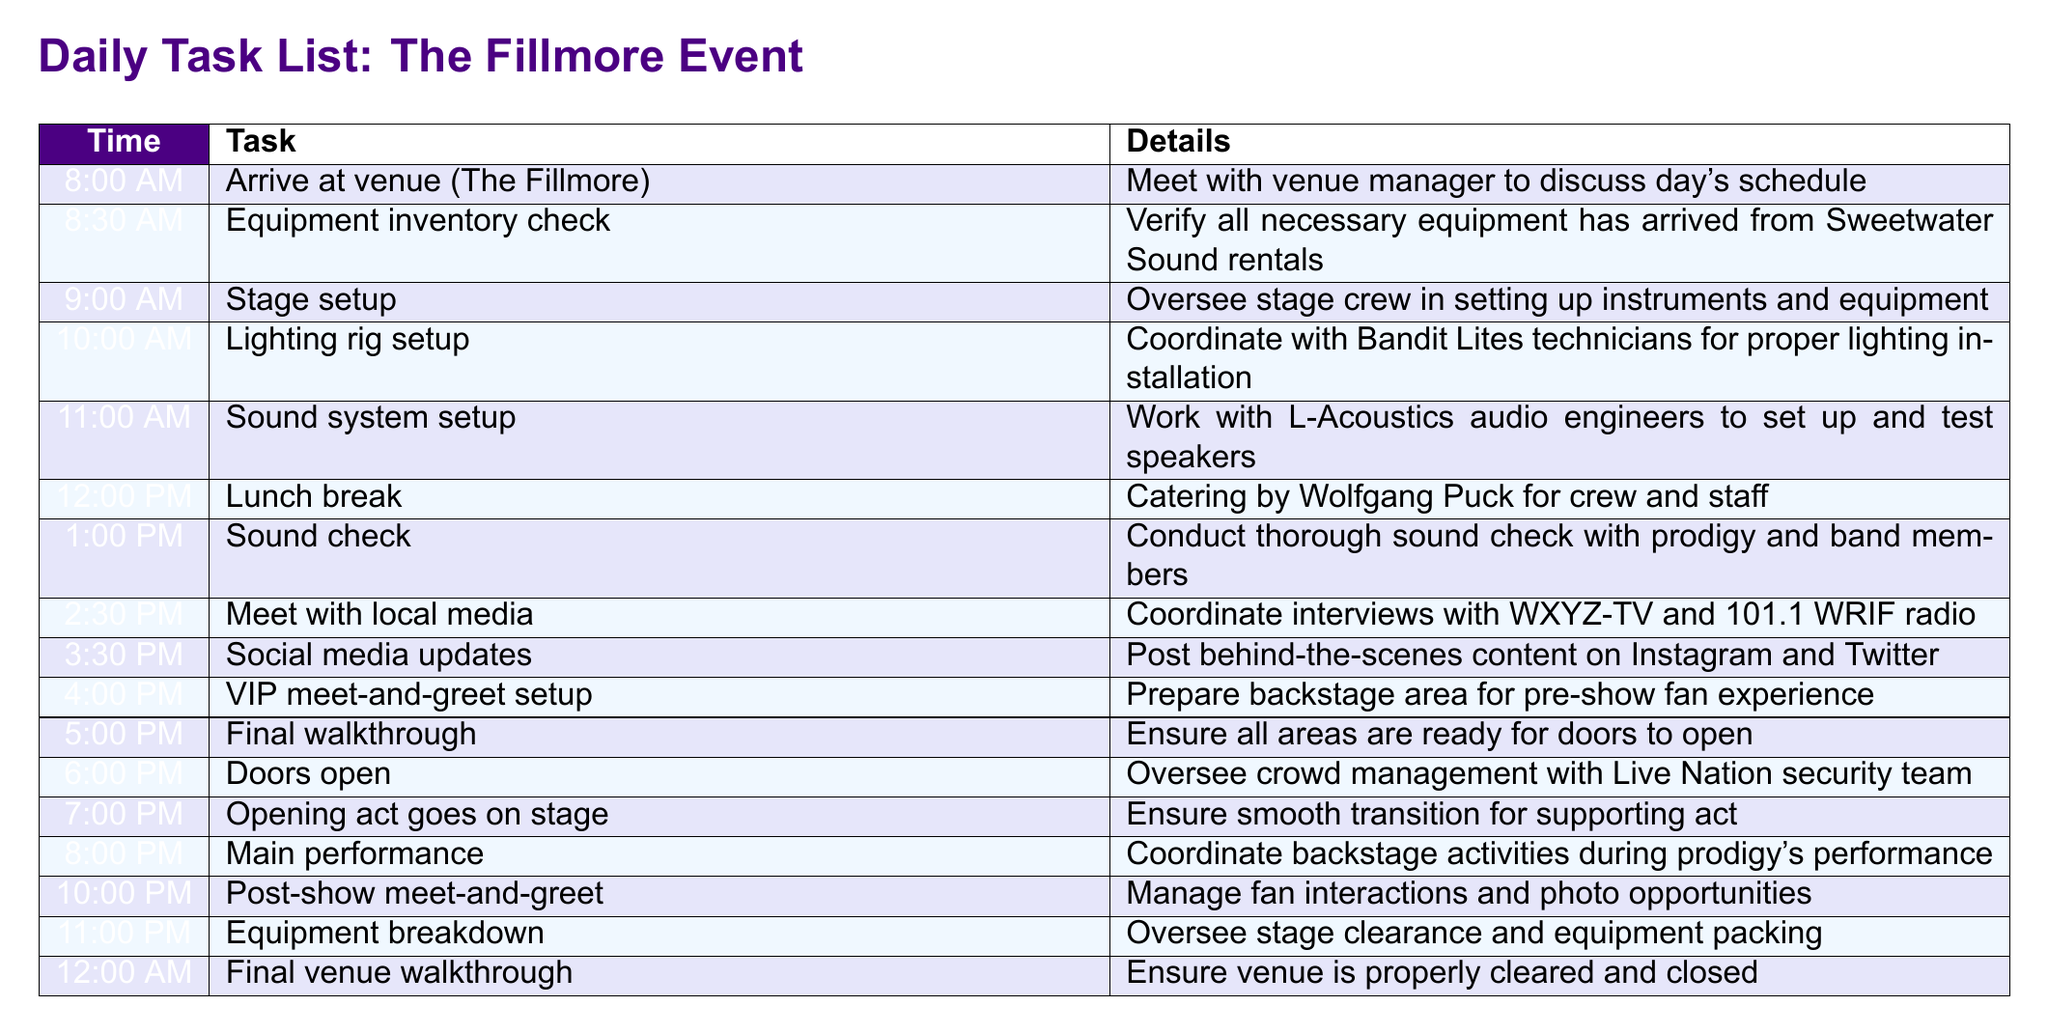What time does the equipment inventory check occur? The equipment inventory check is listed under the time 8:30 AM in the task schedule.
Answer: 8:30 AM Who is responsible for the sound system setup? The sound system setup is conducted in collaboration with L-Acoustics audio engineers according to the details provided in the task.
Answer: L-Acoustics audio engineers What is scheduled immediately after the lunch break? After the lunch break at 12:00 PM, the next task scheduled is the sound check at 1:00 PM.
Answer: Sound check How many hours before the doors open does the final walkthrough take place? The final walkthrough occurs at 5:00 PM, and doors open at 6:00 PM, hence it is one hour before the doors open.
Answer: One hour What task is performed at 10:00 PM? The task scheduled at 10:00 PM is the post-show meet-and-greet.
Answer: Post-show meet-and-greet What is the main activity during the prodigy's performance? The main activity during the prodigy's performance, scheduled for 8:00 PM, is coordinating backstage activities.
Answer: Coordinating backstage activities Which company handles the lighting rig setup? The lighting rig setup is coordinated with Bandit Lites technicians according to the document.
Answer: Bandit Lites When does the VIP meet-and-greet setup begin? The VIP meet-and-greet setup starts at 4:00 PM as listed in the daily task schedule.
Answer: 4:00 PM 